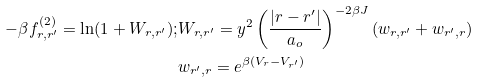Convert formula to latex. <formula><loc_0><loc_0><loc_500><loc_500>- \beta f ^ { ( 2 ) } _ { { r } , { r } ^ { \prime } } = \ln ( 1 + W _ { { r } , { r } ^ { \prime } } ) ; & W _ { { r } , { r } ^ { \prime } } = y ^ { 2 } \left ( \frac { | { r } - { r } ^ { \prime } | } { a _ { o } } \right ) ^ { - 2 \beta J } ( w _ { { r } , { r } ^ { \prime } } + w _ { { r } ^ { \prime } , { r } } ) \\ & w _ { { r } ^ { \prime } , { r } } = e ^ { \beta ( V _ { r } - V _ { { r } ^ { \prime } } ) }</formula> 